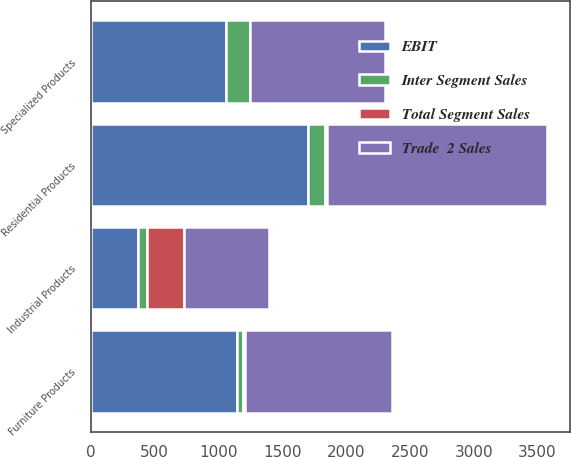Convert chart to OTSL. <chart><loc_0><loc_0><loc_500><loc_500><stacked_bar_chart><ecel><fcel>Residential Products<fcel>Industrial Products<fcel>Furniture Products<fcel>Specialized Products<nl><fcel>EBIT<fcel>1703.7<fcel>367.4<fcel>1142.1<fcel>1056.3<nl><fcel>Total Segment Sales<fcel>17.1<fcel>295<fcel>13.8<fcel>2.7<nl><fcel>Trade  2 Sales<fcel>1720.8<fcel>662.4<fcel>1155.9<fcel>1059<nl><fcel>Inter Segment Sales<fcel>132.8<fcel>68.4<fcel>49.6<fcel>189<nl></chart> 